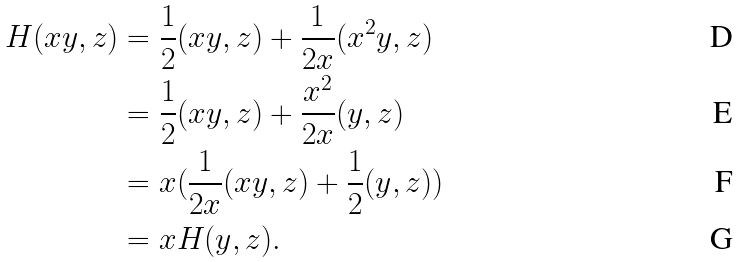<formula> <loc_0><loc_0><loc_500><loc_500>H ( x y , z ) & = \frac { 1 } { 2 } ( x y , z ) + \frac { 1 } { 2 x } ( x ^ { 2 } y , z ) \\ & = \frac { 1 } { 2 } ( x y , z ) + \frac { x ^ { 2 } } { 2 x } ( y , z ) \\ & = x ( \frac { 1 } { 2 x } ( x y , z ) + \frac { 1 } { 2 } ( y , z ) ) \\ & = x H ( y , z ) .</formula> 